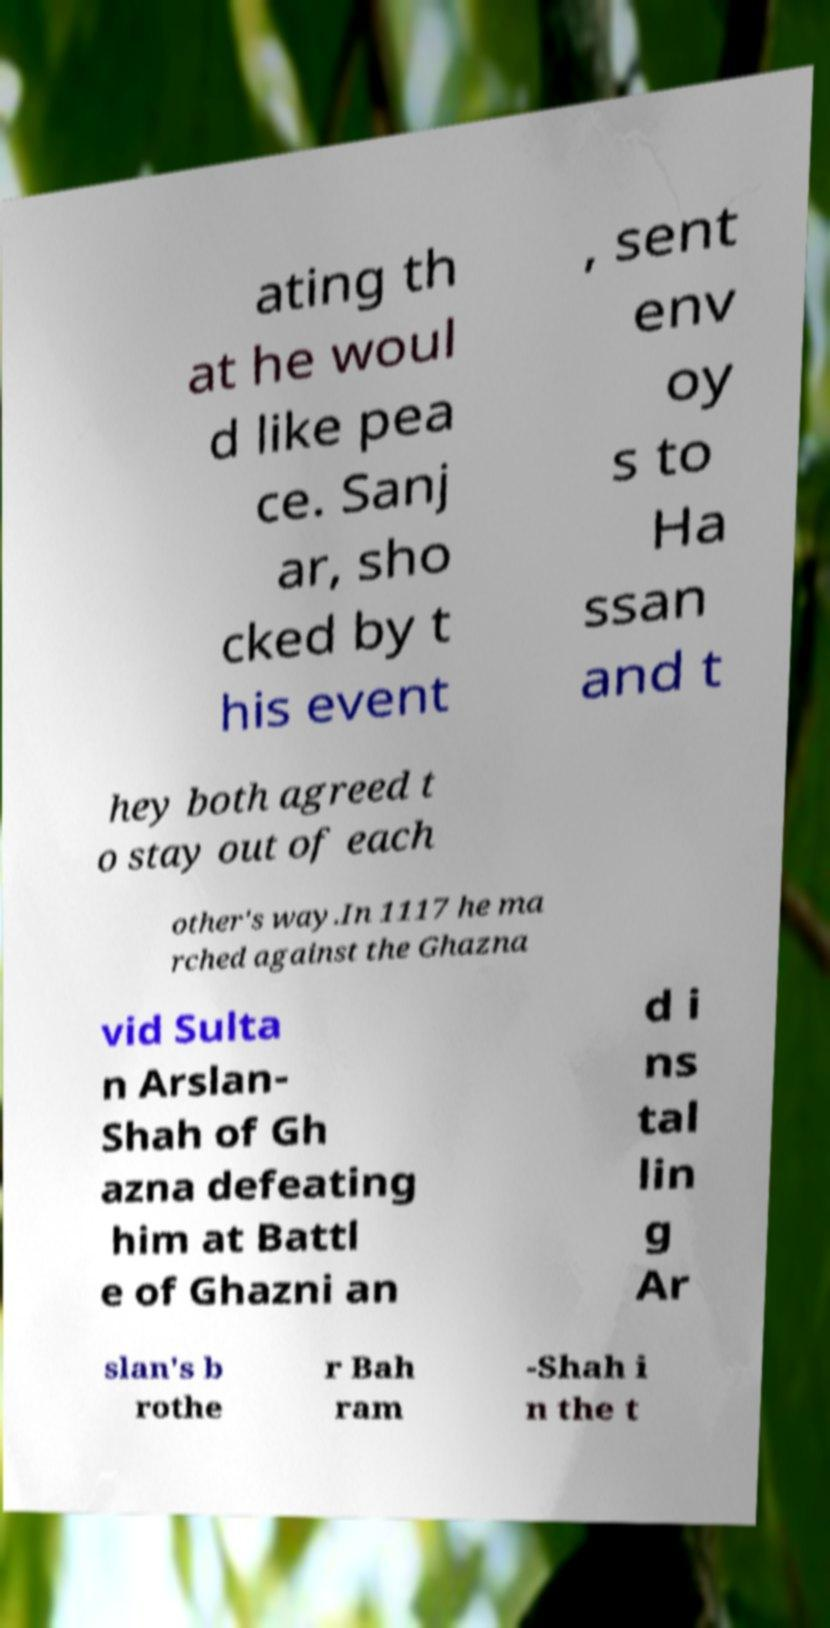Can you accurately transcribe the text from the provided image for me? ating th at he woul d like pea ce. Sanj ar, sho cked by t his event , sent env oy s to Ha ssan and t hey both agreed t o stay out of each other's way.In 1117 he ma rched against the Ghazna vid Sulta n Arslan- Shah of Gh azna defeating him at Battl e of Ghazni an d i ns tal lin g Ar slan's b rothe r Bah ram -Shah i n the t 